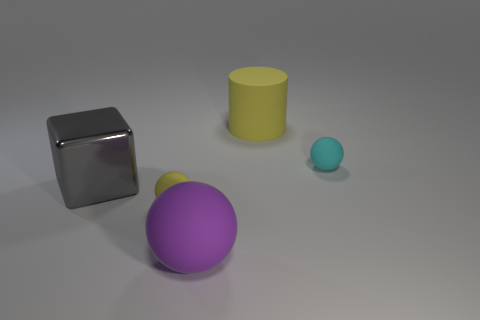Is the number of big gray metallic things in front of the shiny cube the same as the number of tiny yellow objects that are in front of the large purple rubber object? Indeed, the number of large gray metallic items, which is one, positioned in front of the reflective cube matches the quantity of small yellow items, also one, placed before the sizable purple rubber-like sphere. 